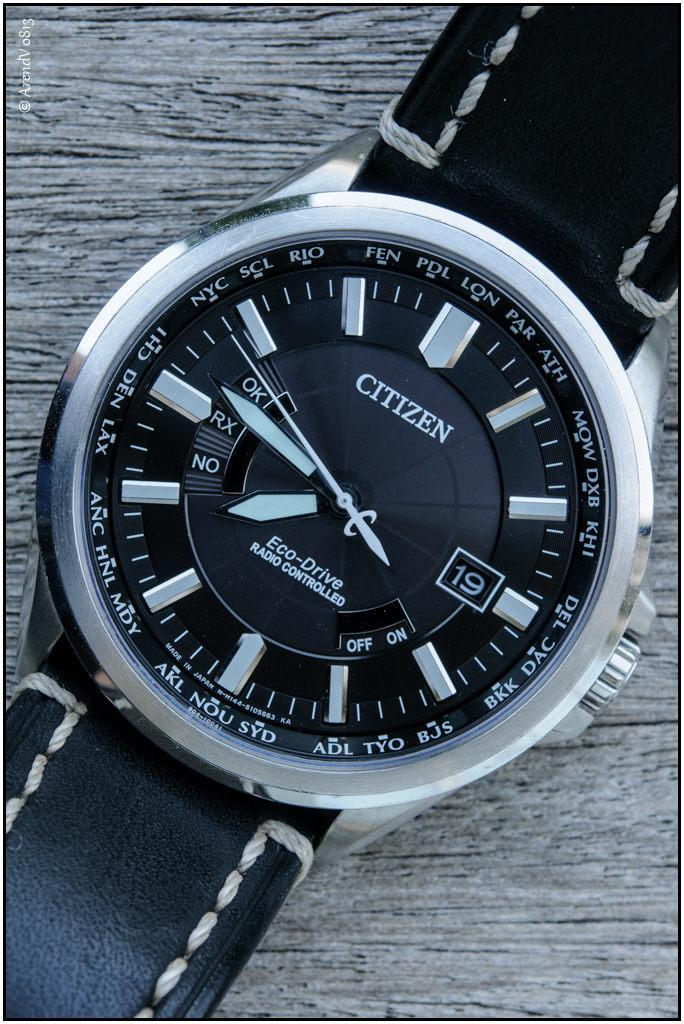<image>
Give a short and clear explanation of the subsequent image. A Citizen's watch with a black face and silver markings. 